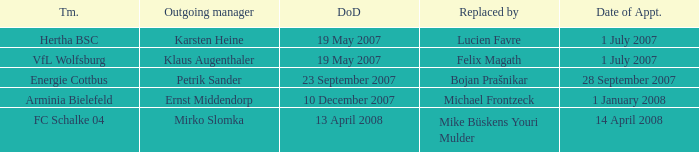When was the departure date when a manager was replaced by Bojan Prašnikar? 23 September 2007. 